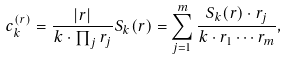<formula> <loc_0><loc_0><loc_500><loc_500>c _ { k } ^ { ( { r } ) } = \frac { | { r } | } { k \cdot \prod _ { j } r _ { j } } S _ { k } ( { r } ) = \sum _ { j = 1 } ^ { m } \frac { S _ { k } ( { r } ) \cdot r _ { j } } { k \cdot r _ { 1 } \cdots r _ { m } } ,</formula> 